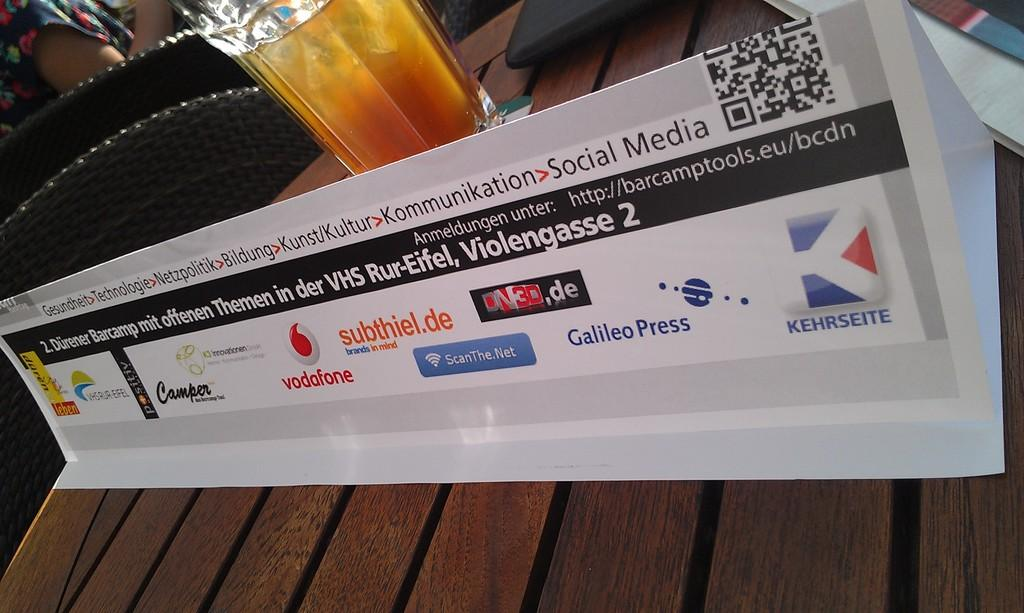<image>
Describe the image concisely. A sign on a table advertises for Camper and Galileo Press among others. 